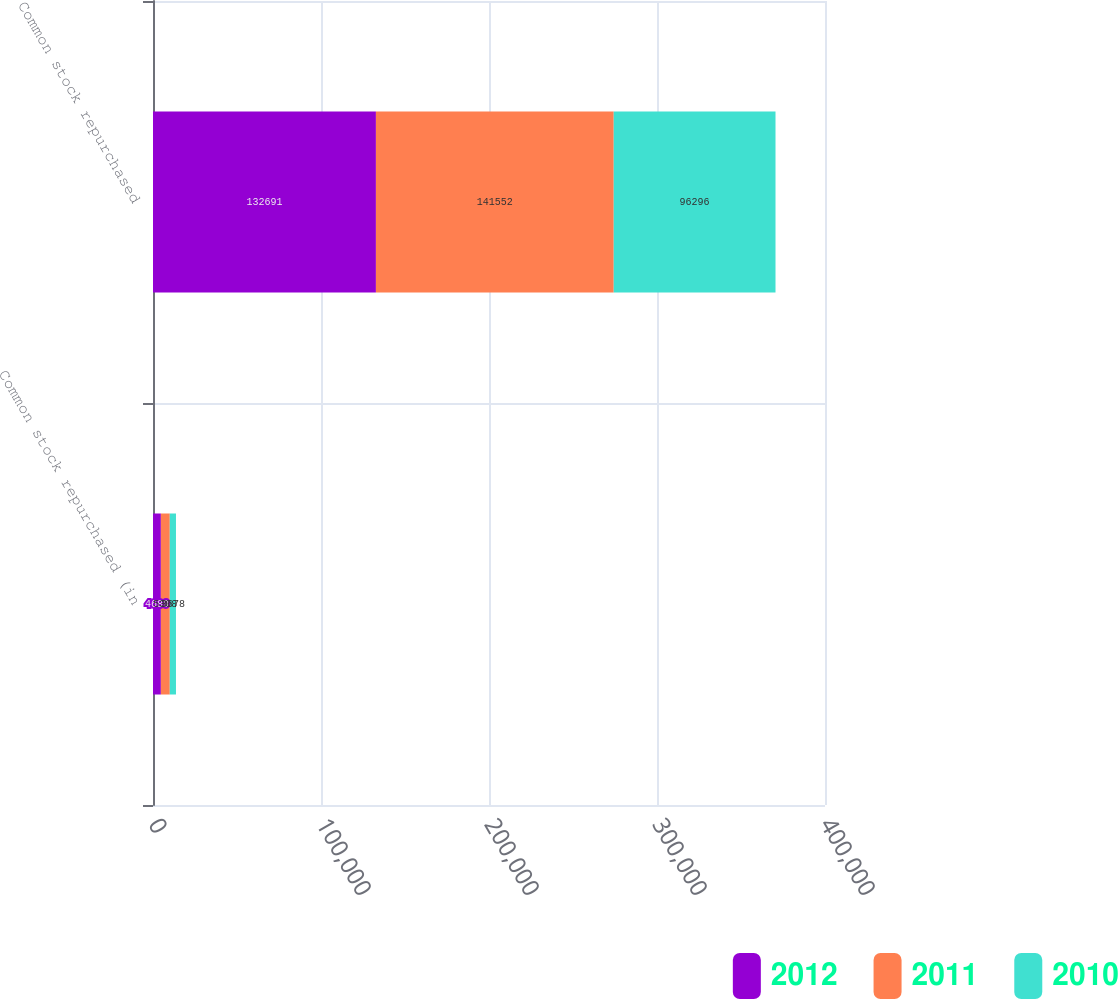Convert chart to OTSL. <chart><loc_0><loc_0><loc_500><loc_500><stacked_bar_chart><ecel><fcel>Common stock repurchased (in<fcel>Common stock repurchased<nl><fcel>2012<fcel>4689<fcel>132691<nl><fcel>2011<fcel>5308<fcel>141552<nl><fcel>2010<fcel>3678<fcel>96296<nl></chart> 